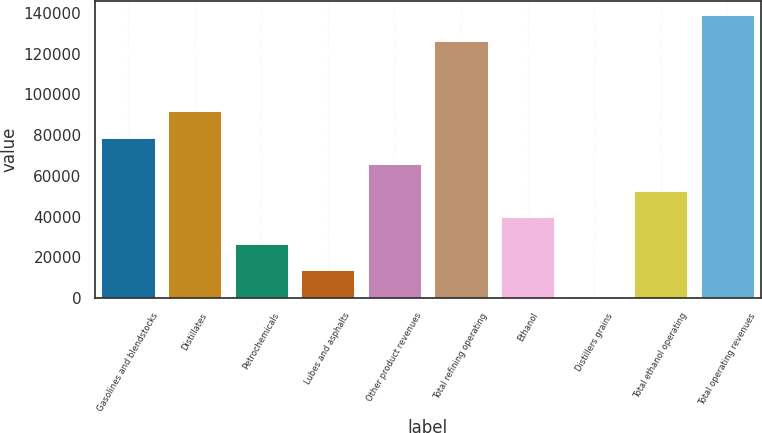<chart> <loc_0><loc_0><loc_500><loc_500><bar_chart><fcel>Gasolines and blendstocks<fcel>Distillates<fcel>Petrochemicals<fcel>Lubes and asphalts<fcel>Other product revenues<fcel>Total refining operating<fcel>Ethanol<fcel>Distillers grains<fcel>Total ethanol operating<fcel>Total operating revenues<nl><fcel>78765.6<fcel>91785.2<fcel>26687.2<fcel>13667.6<fcel>65746<fcel>126004<fcel>39706.8<fcel>648<fcel>52726.4<fcel>139024<nl></chart> 